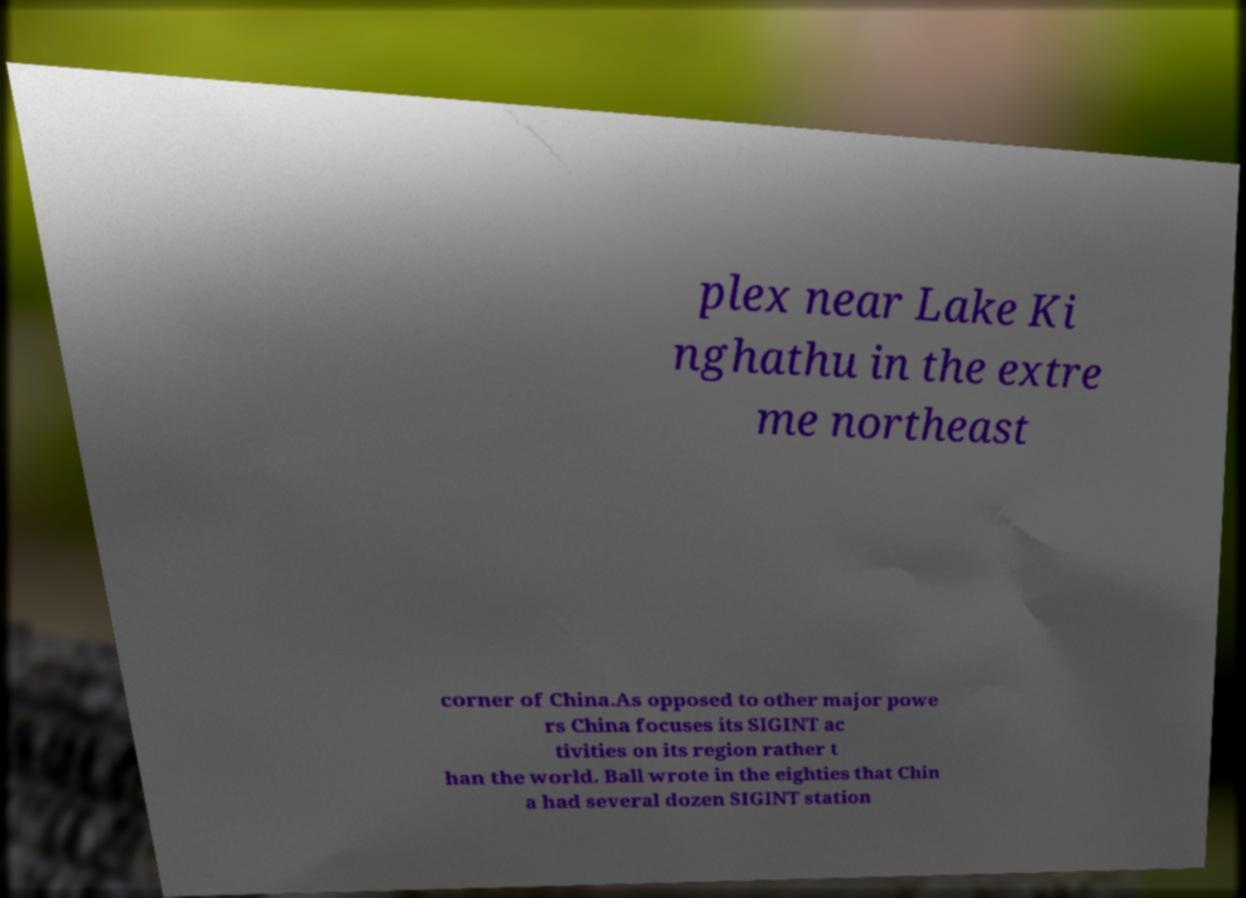For documentation purposes, I need the text within this image transcribed. Could you provide that? plex near Lake Ki nghathu in the extre me northeast corner of China.As opposed to other major powe rs China focuses its SIGINT ac tivities on its region rather t han the world. Ball wrote in the eighties that Chin a had several dozen SIGINT station 